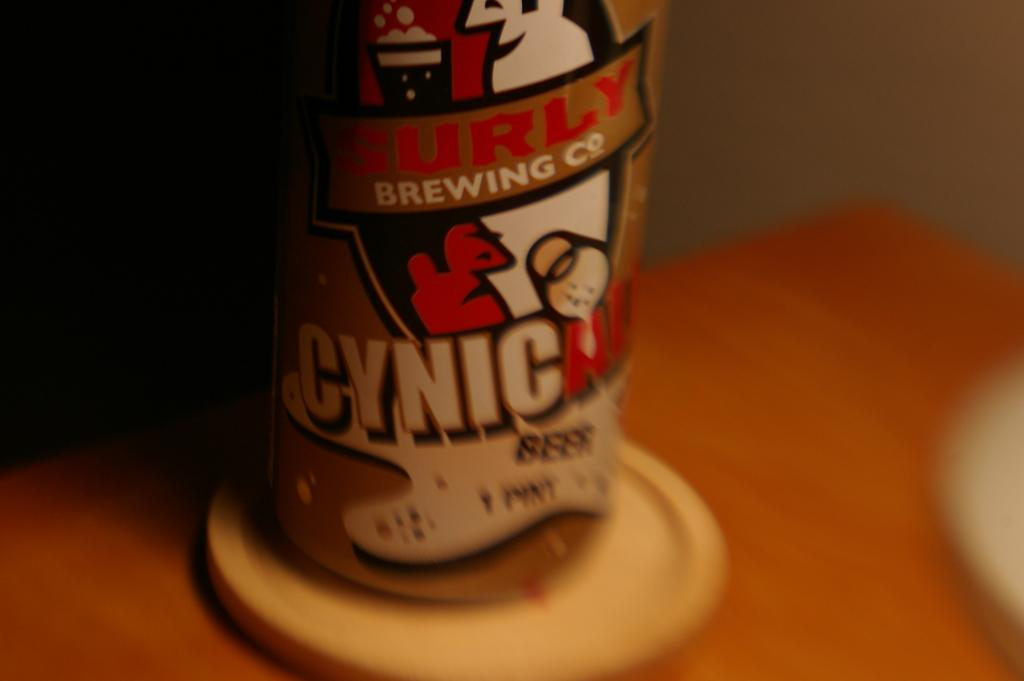<image>
Offer a succinct explanation of the picture presented. A colorful can of Cynical Beer sits on a coaster. 